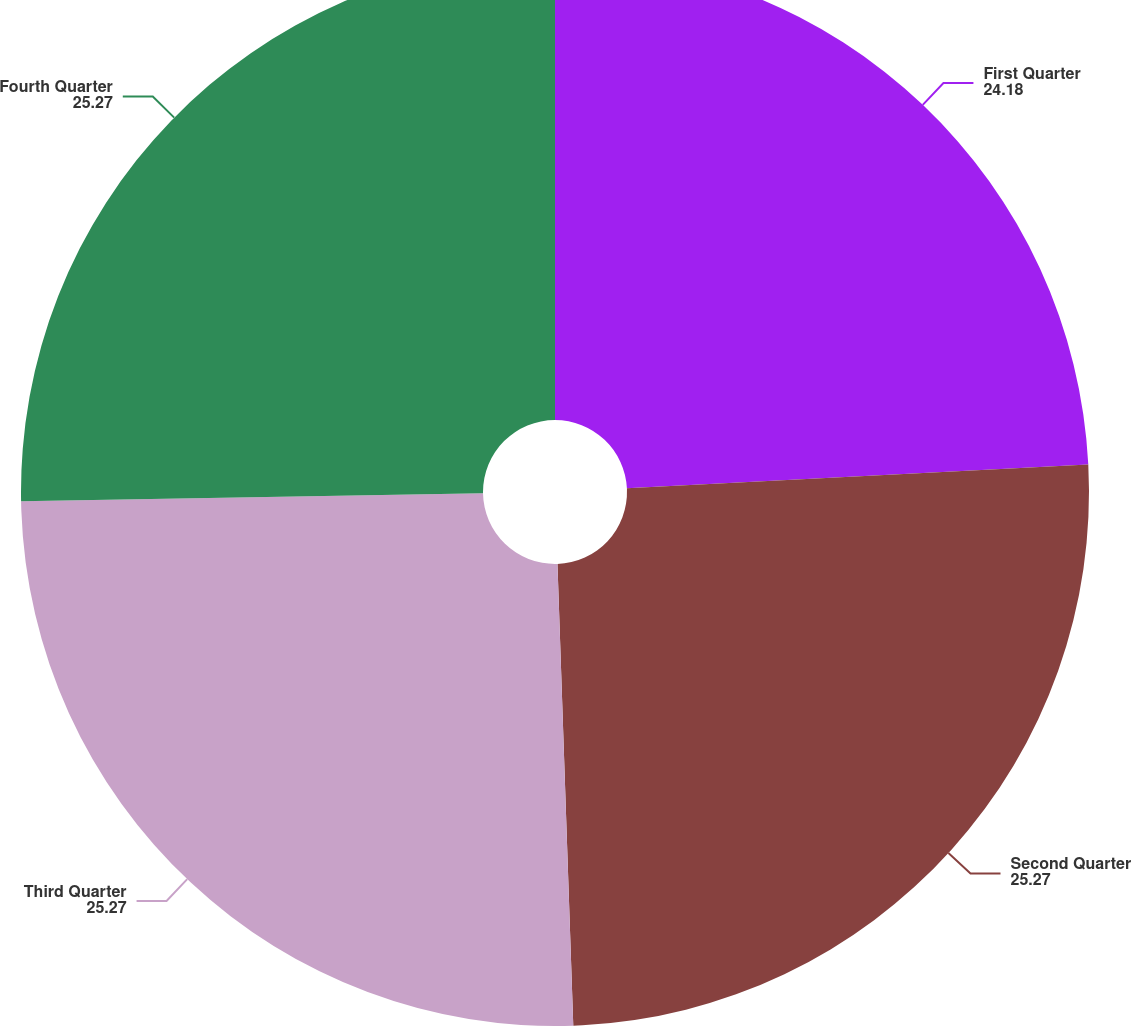<chart> <loc_0><loc_0><loc_500><loc_500><pie_chart><fcel>First Quarter<fcel>Second Quarter<fcel>Third Quarter<fcel>Fourth Quarter<nl><fcel>24.18%<fcel>25.27%<fcel>25.27%<fcel>25.27%<nl></chart> 